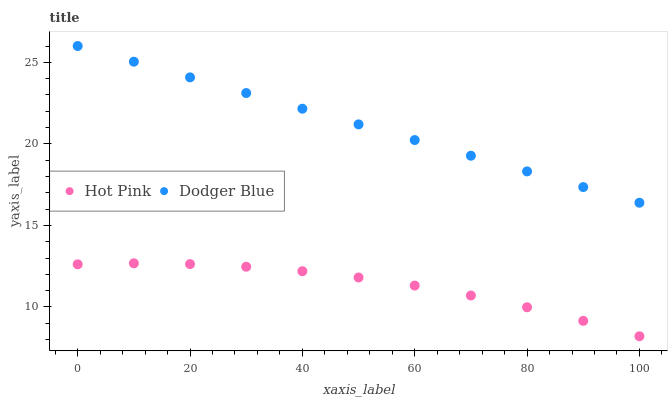Does Hot Pink have the minimum area under the curve?
Answer yes or no. Yes. Does Dodger Blue have the maximum area under the curve?
Answer yes or no. Yes. Does Dodger Blue have the minimum area under the curve?
Answer yes or no. No. Is Dodger Blue the smoothest?
Answer yes or no. Yes. Is Hot Pink the roughest?
Answer yes or no. Yes. Is Dodger Blue the roughest?
Answer yes or no. No. Does Hot Pink have the lowest value?
Answer yes or no. Yes. Does Dodger Blue have the lowest value?
Answer yes or no. No. Does Dodger Blue have the highest value?
Answer yes or no. Yes. Is Hot Pink less than Dodger Blue?
Answer yes or no. Yes. Is Dodger Blue greater than Hot Pink?
Answer yes or no. Yes. Does Hot Pink intersect Dodger Blue?
Answer yes or no. No. 